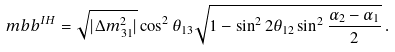<formula> <loc_0><loc_0><loc_500><loc_500>\ m b b ^ { I H } = \sqrt { | \Delta m _ { 3 1 } ^ { 2 } | } \cos ^ { 2 } \theta _ { 1 3 } \sqrt { 1 - \sin ^ { 2 } 2 \theta _ { 1 2 } \sin ^ { 2 } \frac { \alpha _ { 2 } - \alpha _ { 1 } } { 2 } } \, .</formula> 